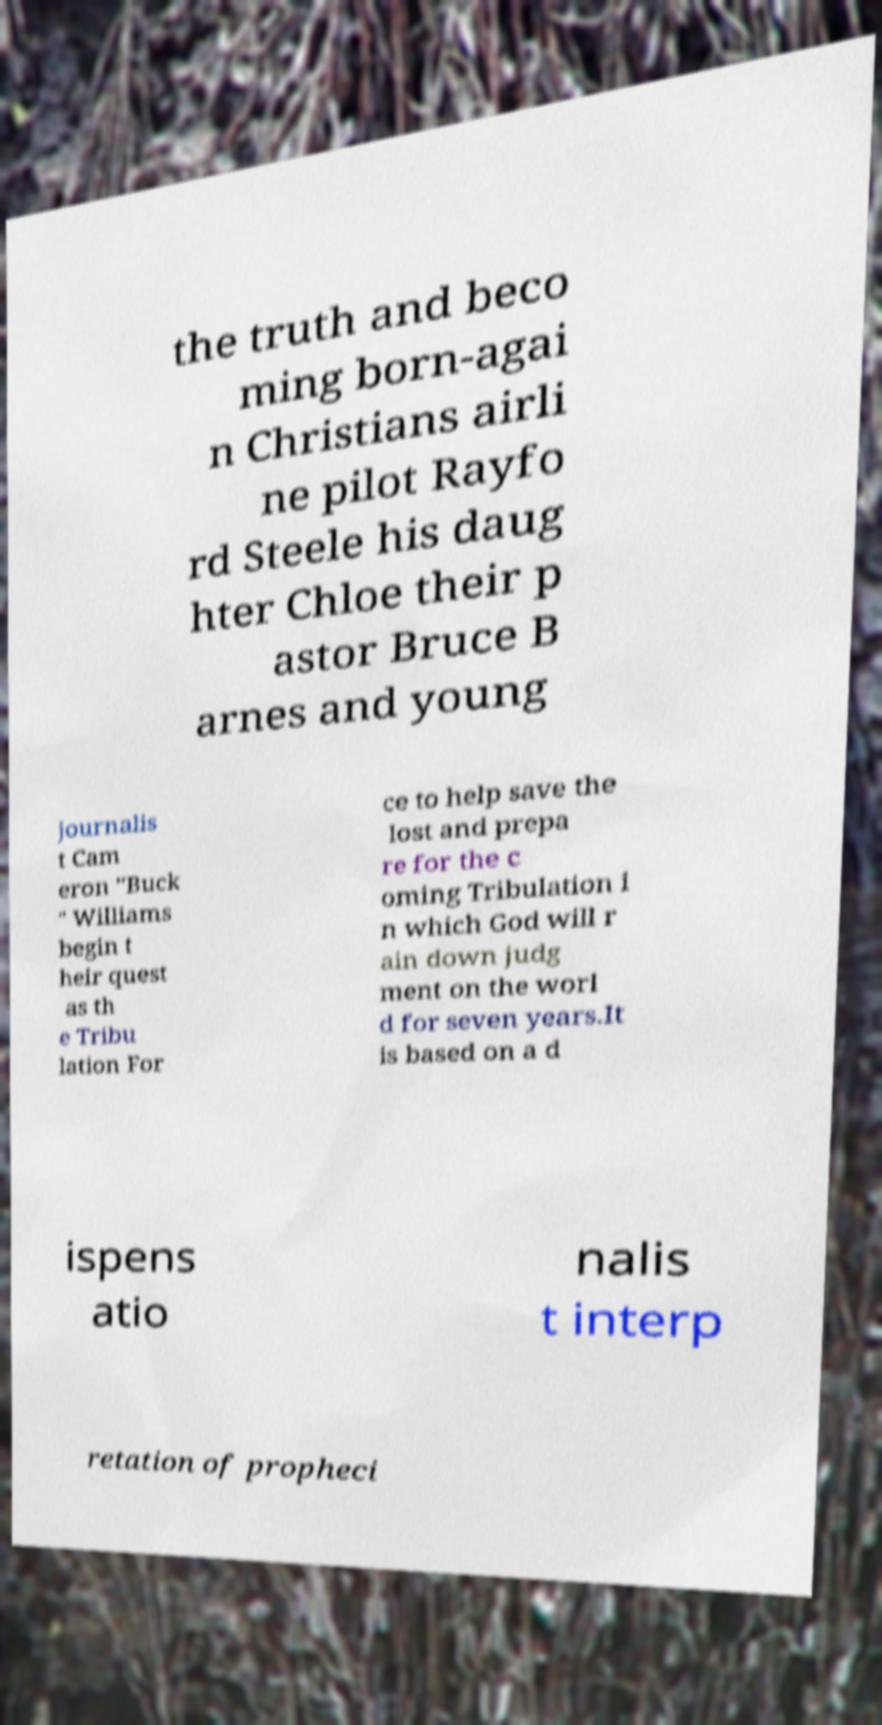Could you extract and type out the text from this image? the truth and beco ming born-agai n Christians airli ne pilot Rayfo rd Steele his daug hter Chloe their p astor Bruce B arnes and young journalis t Cam eron "Buck " Williams begin t heir quest as th e Tribu lation For ce to help save the lost and prepa re for the c oming Tribulation i n which God will r ain down judg ment on the worl d for seven years.It is based on a d ispens atio nalis t interp retation of propheci 